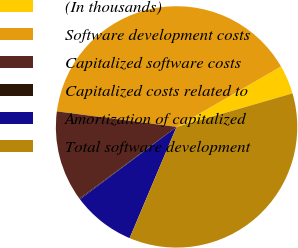<chart> <loc_0><loc_0><loc_500><loc_500><pie_chart><fcel>(In thousands)<fcel>Software development costs<fcel>Capitalized software costs<fcel>Capitalized costs related to<fcel>Amortization of capitalized<fcel>Total software development<nl><fcel>3.87%<fcel>39.6%<fcel>12.17%<fcel>0.12%<fcel>8.41%<fcel>35.84%<nl></chart> 